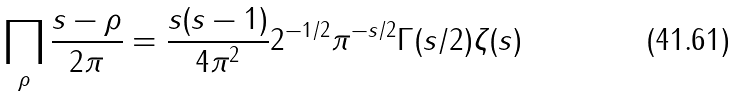<formula> <loc_0><loc_0><loc_500><loc_500>\prod _ { \rho } \frac { s - \rho } { 2 \pi } = \frac { s ( s - 1 ) } { 4 \pi ^ { 2 } } 2 ^ { - 1 / 2 } \pi ^ { - s / 2 } \Gamma ( s / 2 ) \zeta ( s )</formula> 